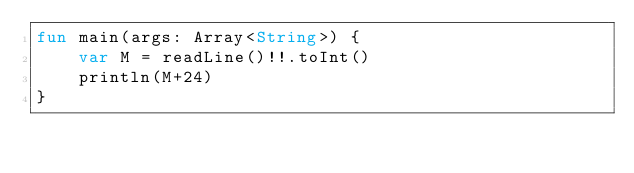<code> <loc_0><loc_0><loc_500><loc_500><_Kotlin_>fun main(args: Array<String>) {
    var M = readLine()!!.toInt()
    println(M+24)
}
</code> 